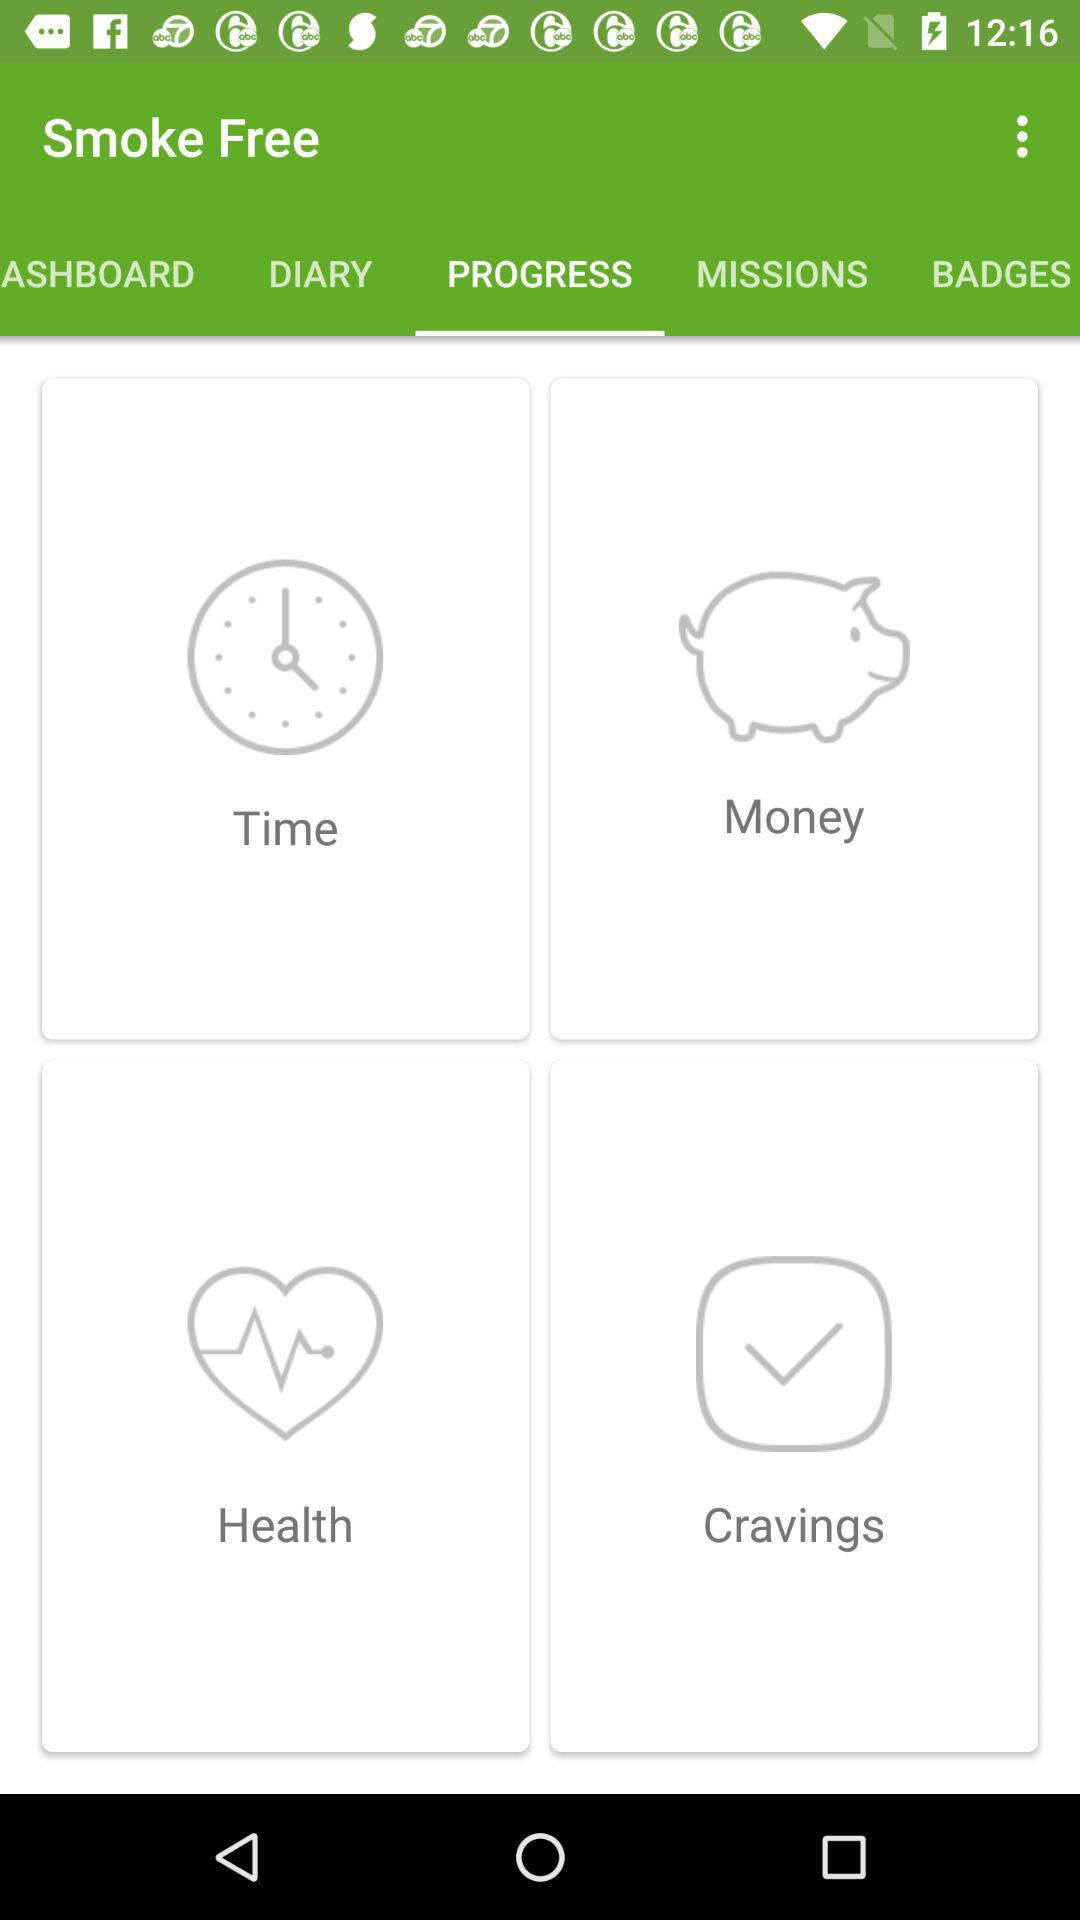Which tab am I using? You are using the "PROGRESS" tab. 